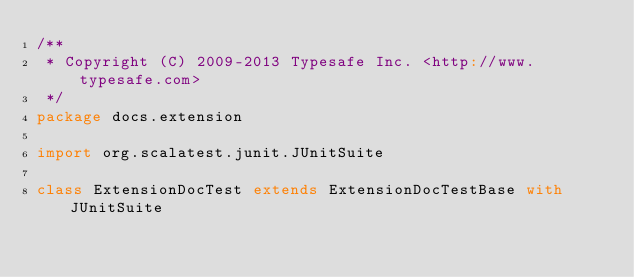Convert code to text. <code><loc_0><loc_0><loc_500><loc_500><_Scala_>/**
 * Copyright (C) 2009-2013 Typesafe Inc. <http://www.typesafe.com>
 */
package docs.extension

import org.scalatest.junit.JUnitSuite

class ExtensionDocTest extends ExtensionDocTestBase with JUnitSuite
</code> 